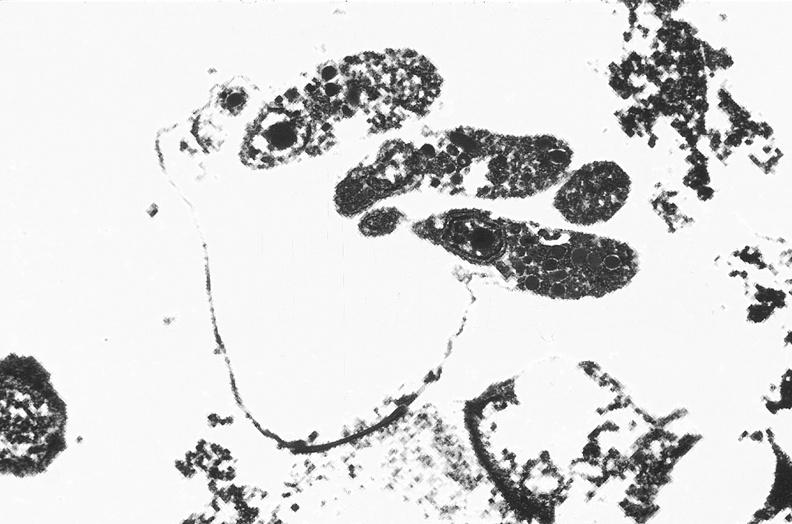does photo show colon, cryptosporidia?
Answer the question using a single word or phrase. No 